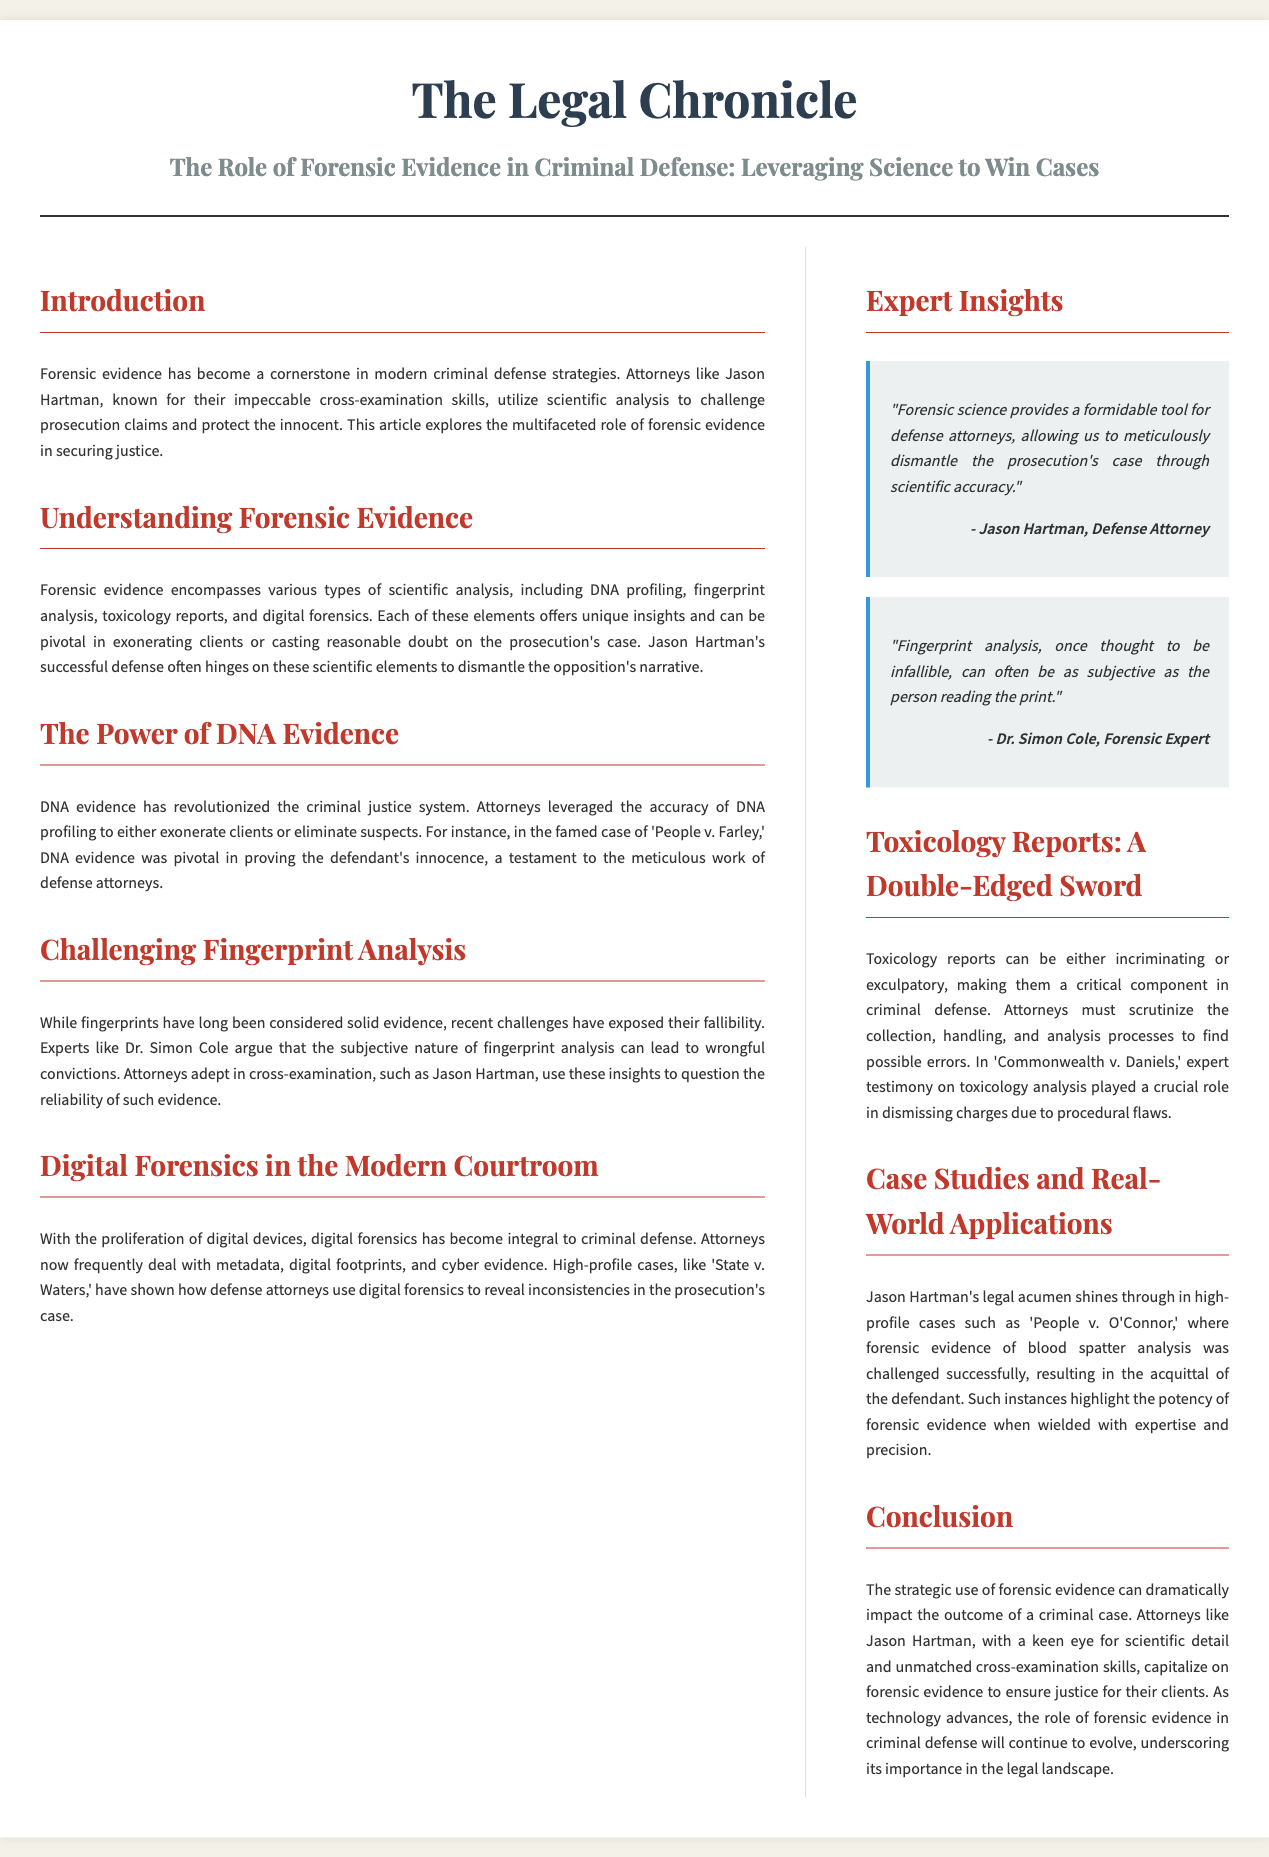What is the title of the article? The title of the article is presented prominently at the top of the document.
Answer: The Role of Forensic Evidence in Criminal Defense: Leveraging Science to Win Cases Who is the defense attorney mentioned in the article? The article specifically highlights a defense attorney known for cross-examination skills.
Answer: Jason Hartman What is DNA evidence used for? The article describes the primary utility of DNA evidence in criminal defense cases.
Answer: Exonerate clients or eliminate suspects What does Dr. Simon Cole argue about fingerprint analysis? Dr. Simon Cole's statement regarding fingerprint analysis is mentioned in the sidebar quotes.
Answer: Subjective nature In which case was expert testimony on toxicology analysis crucial? The document discusses a specific case where toxicology played a significant role in the defense.
Answer: Commonwealth v. Daniels What two elements are mentioned in the article as unique types of forensic evidence? The article lists several types of forensic evidence; two of them are highlighted in one of the paragraphs.
Answer: DNA profiling, fingerprint analysis What type of reports can be a double-edged sword according to the article? The article refers to a specific type of evidence that can have opposing implications in legal cases.
Answer: Toxicology reports Which high-profile case involved blood spatter analysis? The article provides an example of a case where forensic evidence of a specific type was effectively challenged.
Answer: People v. O'Connor 